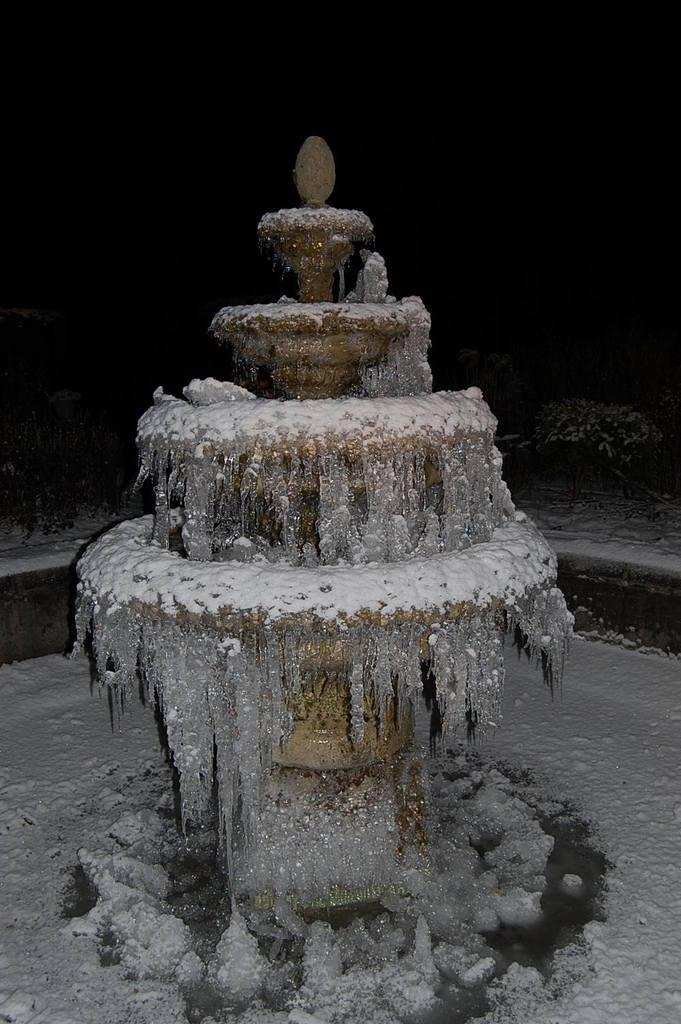What is the main feature in the image? There is a fountain in the image. How is the fountain affected by the weather? The fountain is covered in ice and snow. What type of surface is visible in the image? There is a snow surface visible in the image. How many chickens are standing near the fountain in the image? There are no chickens present in the image. What type of haircut does the fountain have in the image? The fountain does not have a haircut, as it is an inanimate object. 